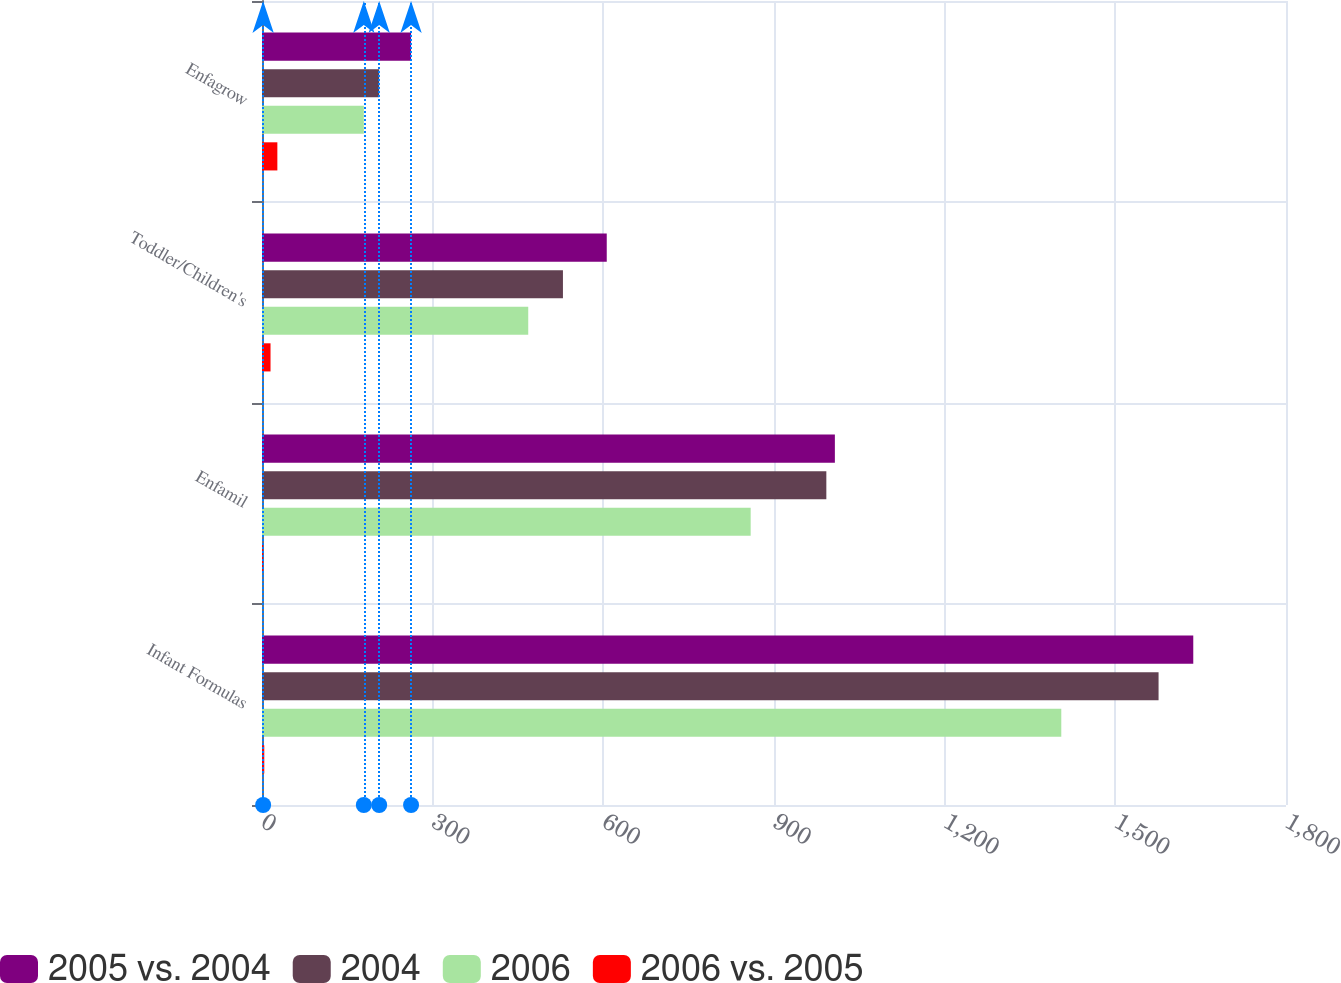Convert chart to OTSL. <chart><loc_0><loc_0><loc_500><loc_500><stacked_bar_chart><ecel><fcel>Infant Formulas<fcel>Enfamil<fcel>Toddler/Children's<fcel>Enfagrow<nl><fcel>2005 vs. 2004<fcel>1637<fcel>1007<fcel>606<fcel>262<nl><fcel>2004<fcel>1576<fcel>992<fcel>529<fcel>206<nl><fcel>2006<fcel>1405<fcel>859<fcel>468<fcel>179<nl><fcel>2006 vs. 2005<fcel>4<fcel>2<fcel>15<fcel>27<nl></chart> 